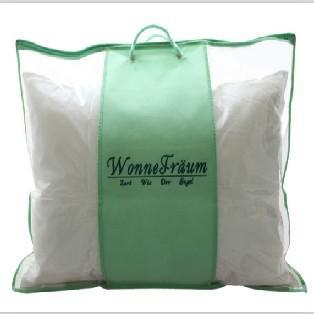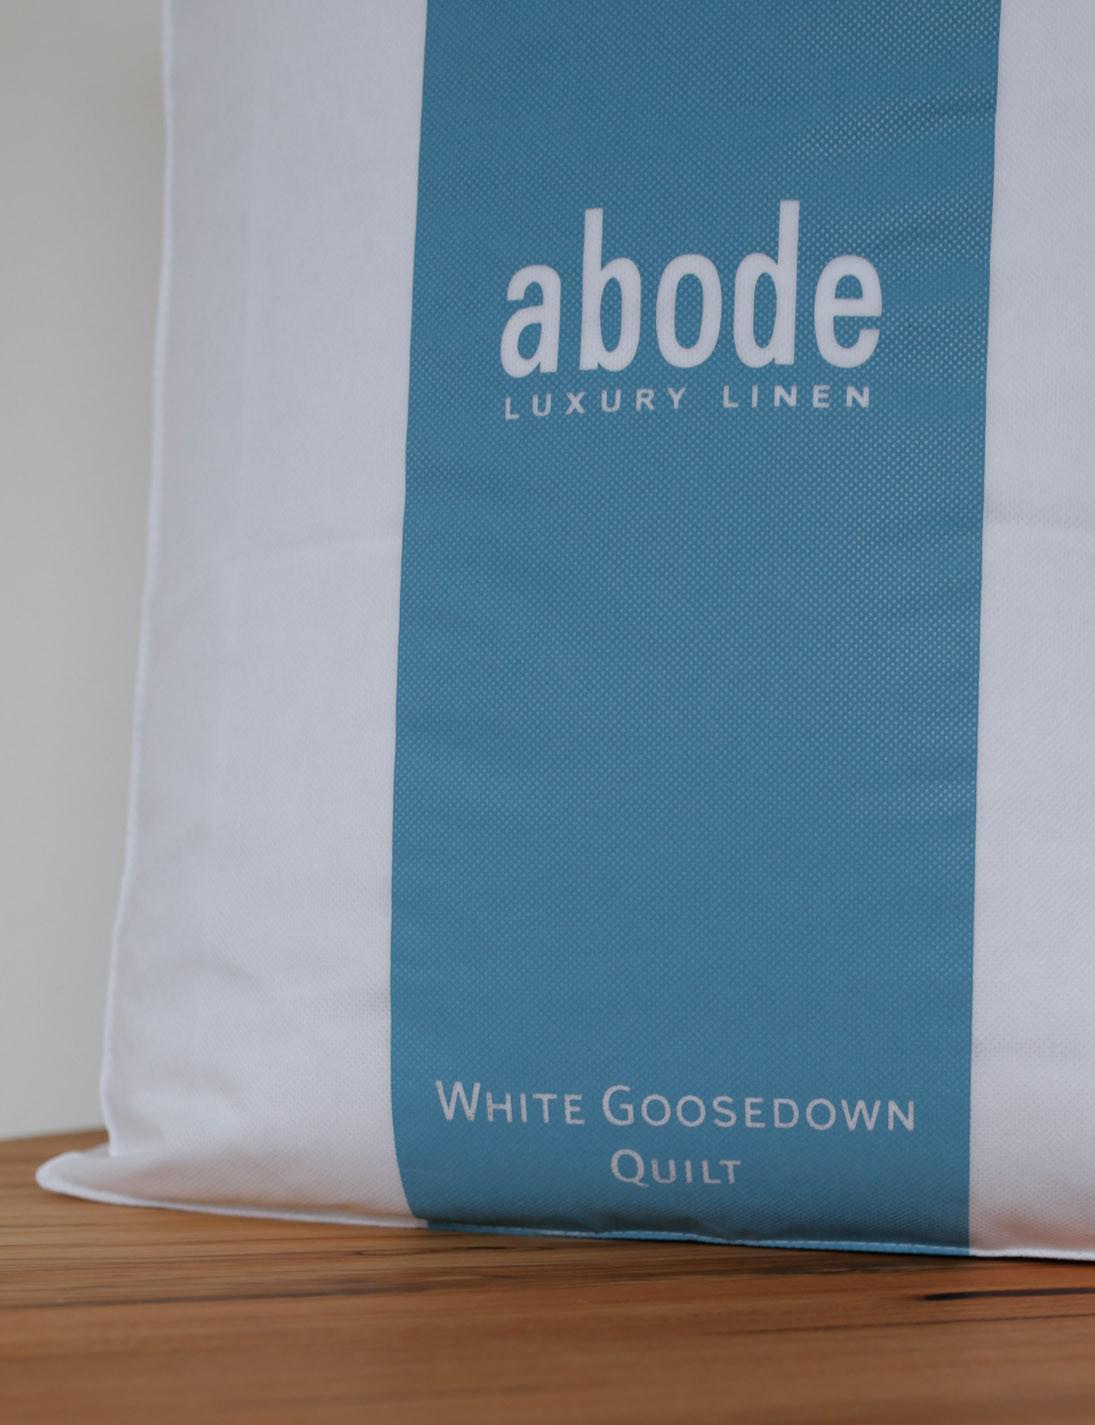The first image is the image on the left, the second image is the image on the right. For the images displayed, is the sentence "One image shows an upright pillow shape with a wide blue stripe down the center, and the other image includes an off-white pillow shape with no stripe." factually correct? Answer yes or no. No. 